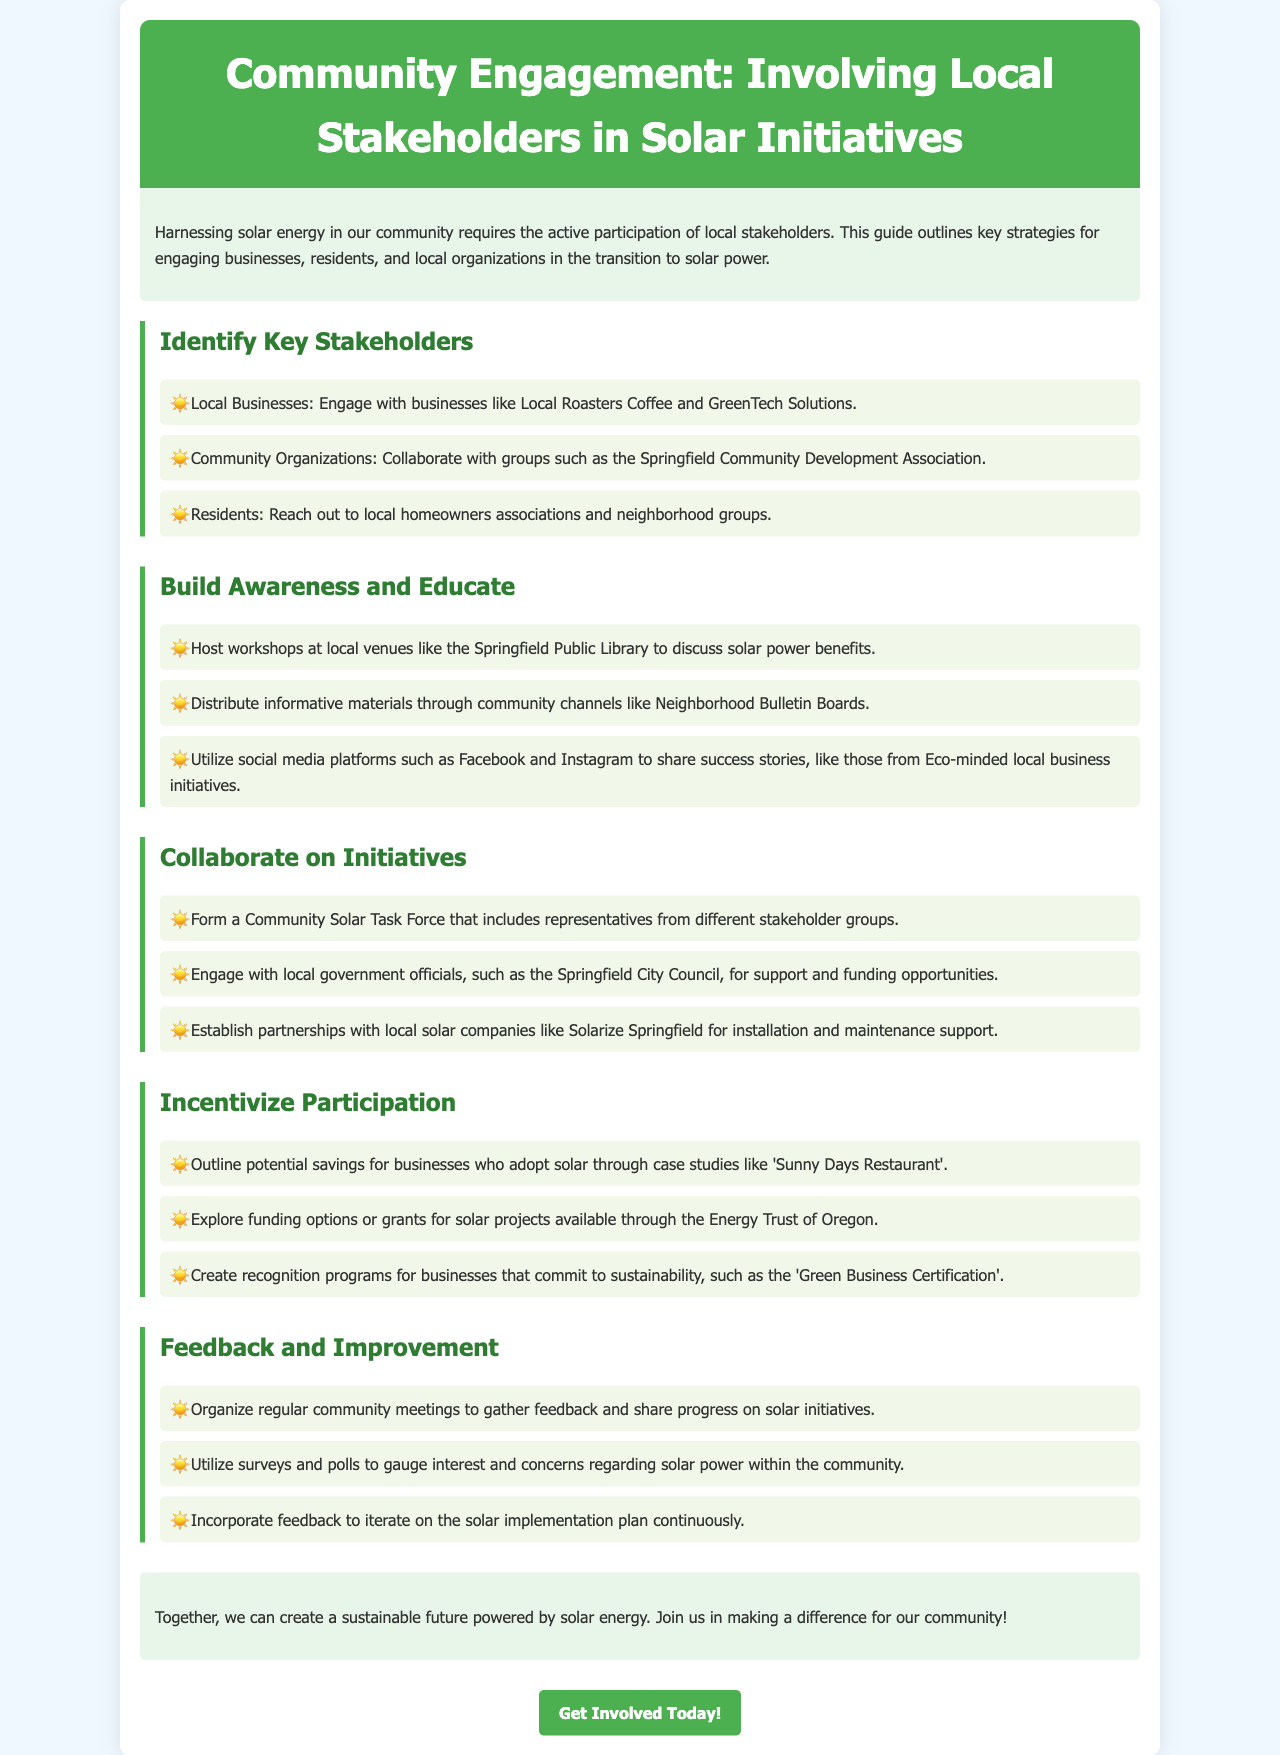What is the main focus of the brochure? The brochure focuses on involving local stakeholders in solar initiatives within the community.
Answer: Involving local stakeholders in solar initiatives What type of organizations should be engaged according to the guide? The guide suggests collaborating with community organizations such as the Springfield Community Development Association.
Answer: Community organizations What is the purpose of hosting workshops? The purpose is to discuss solar power benefits and educate the community.
Answer: Discuss solar power benefits Which local solar company is mentioned for partnerships? The guide mentions Solarize Springfield for installation and maintenance support.
Answer: Solarize Springfield What type of feedback mechanisms are suggested? The brochure suggests organizing regular community meetings and using surveys or polls for feedback.
Answer: Regular community meetings and surveys What is a key activity to build awareness? Hosting workshops at local venues is suggested as a key activity.
Answer: Host workshops How can businesses be incentivized to adopt solar? The proposed method includes outlining potential savings through relevant case studies.
Answer: Outlining potential savings What is the role of local government officials in the initiative? Local government officials are engaged for support and funding opportunities.
Answer: Support and funding opportunities How can feedback affect the solar implementation plan? Feedback can be incorporated to iterate on the solar implementation plan continuously.
Answer: Iterate on the solar implementation plan What is the call to action at the end of the brochure? The call to action invites the community to get involved today.
Answer: Get involved today! 